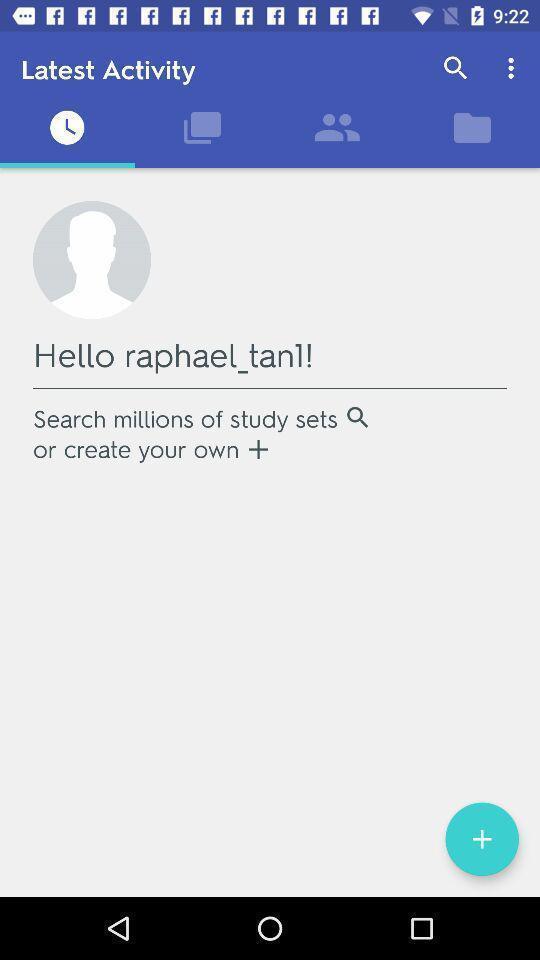Give me a narrative description of this picture. Page showing latest activity in a learning app. 